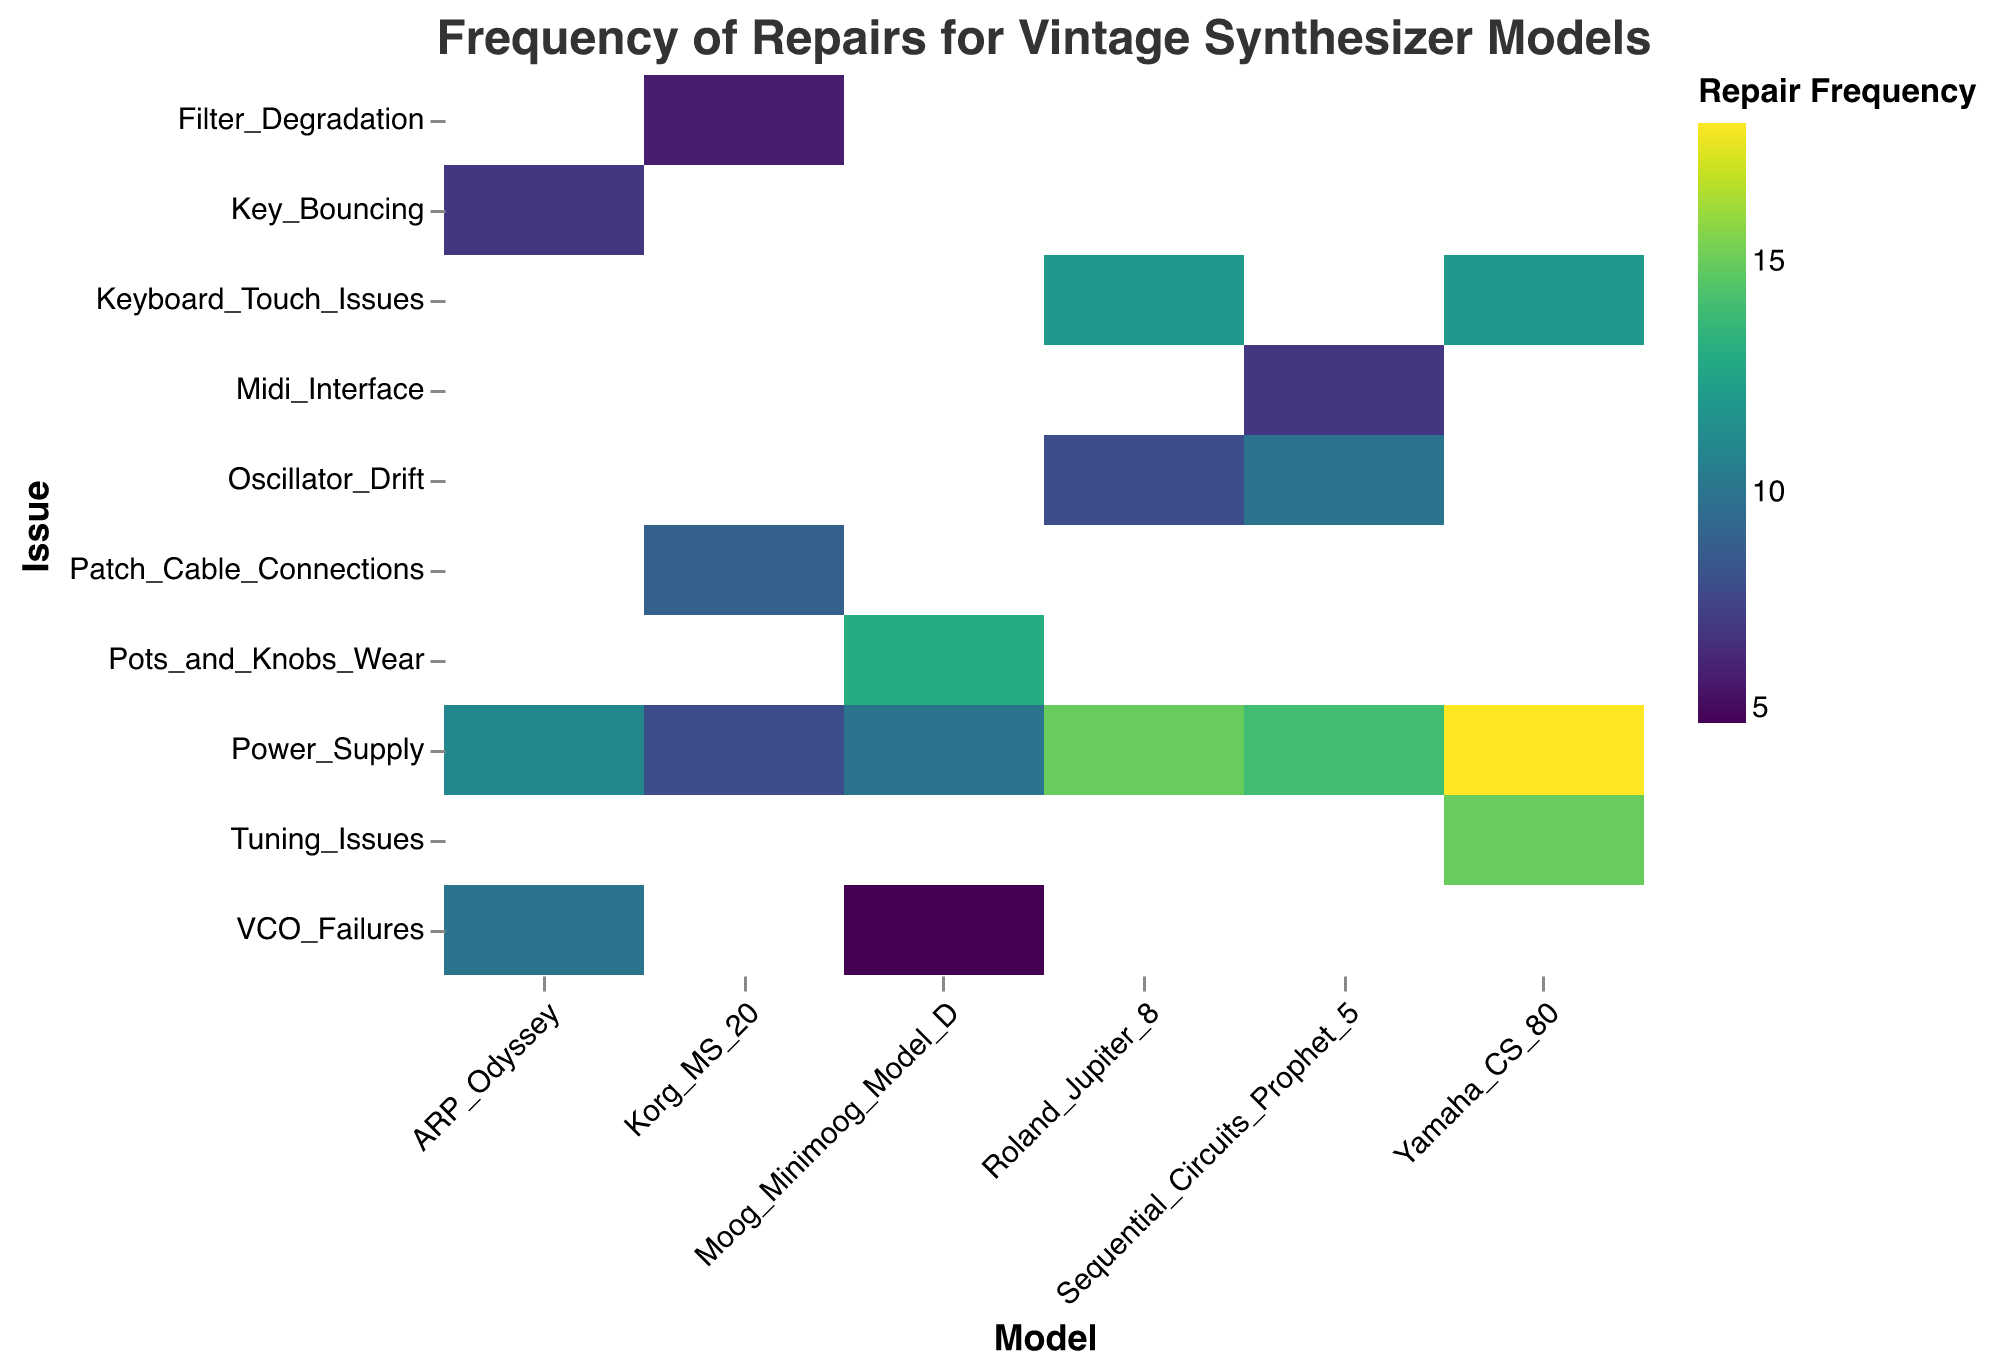Which synthesizer model has the highest frequency of power supply repairs? Look at the 'Power_Supply' row and identify the highest value, which is 18 for "Yamaha_CS_80".
Answer: Yamaha CS-80 How many models have keyboard touch issues? Count the unique models listed under 'Keyboard_Touch_Issues': "Roland_Jupiter_8" and "Yamaha_CS_80".
Answer: 2 Which issue has the overall lowest frequency of repairs for the "Moog Minimoog Model D"? Check all frequencies under "Moog_Minimoog_Model_D" and find the lowest value, which is 5 for "VCO_Failures".
Answer: VCO Failures What is the total frequency of oscillator drift repairs across all models? Sum the 'Oscillator_Drift' frequencies for all models: 8 (Roland_Jupiter_8) + 10 (Sequential_Circuits_Prophet_5) = 18.
Answer: 18 Which model has the fewest different types of repair issues? Count the number of unique issues for each model and find the model with the least, which is "Korg_MS_20" (3 issues).
Answer: Korg MS-20 For the "Sequential Circuits Prophet-5", what is the difference in frequency between power supply issues and MIDI interface issues? Subtract the frequency of 'Midi_Interface' (7) from 'Power_Supply' (14) for Sequential_Circuits_Prophet_5: 14 - 7 = 7.
Answer: 7 Which issue category shows up most frequently across all models? Count the occurrences of each issue and identify the most frequent one, which is 'Power_Supply' with separate frequencies for each model.
Answer: Power Supply Between "Roland Jupiter 8" and "ARP Odyssey," which model has higher total repair frequency? Sum the frequencies for all issues for each model: "Roland_Jupiter_8" (15+12+8=35) and "ARP_Odyssey" (10+11+7=28).
Answer: Roland Jupiter 8 What is the color associated with the highest frequency of repairs on the heatmap? Check the color scale 'viridis' and locate the color for the highest frequency (18) for 'Power_Supply' of "Yamaha_CS_80". Typically, this is a shade of yellow in the viridis color scheme.
Answer: Yellow Which model has the highest average frequency of repairs per issue? Calculate the average repair frequency per issue for each model and find the highest: (Sum of Frequencies) / (Number of Issues). The 'Yamaha_CS_80' has the highest average (18+12+15)/3 ≈ 15.
Answer: Yamaha CS-80 